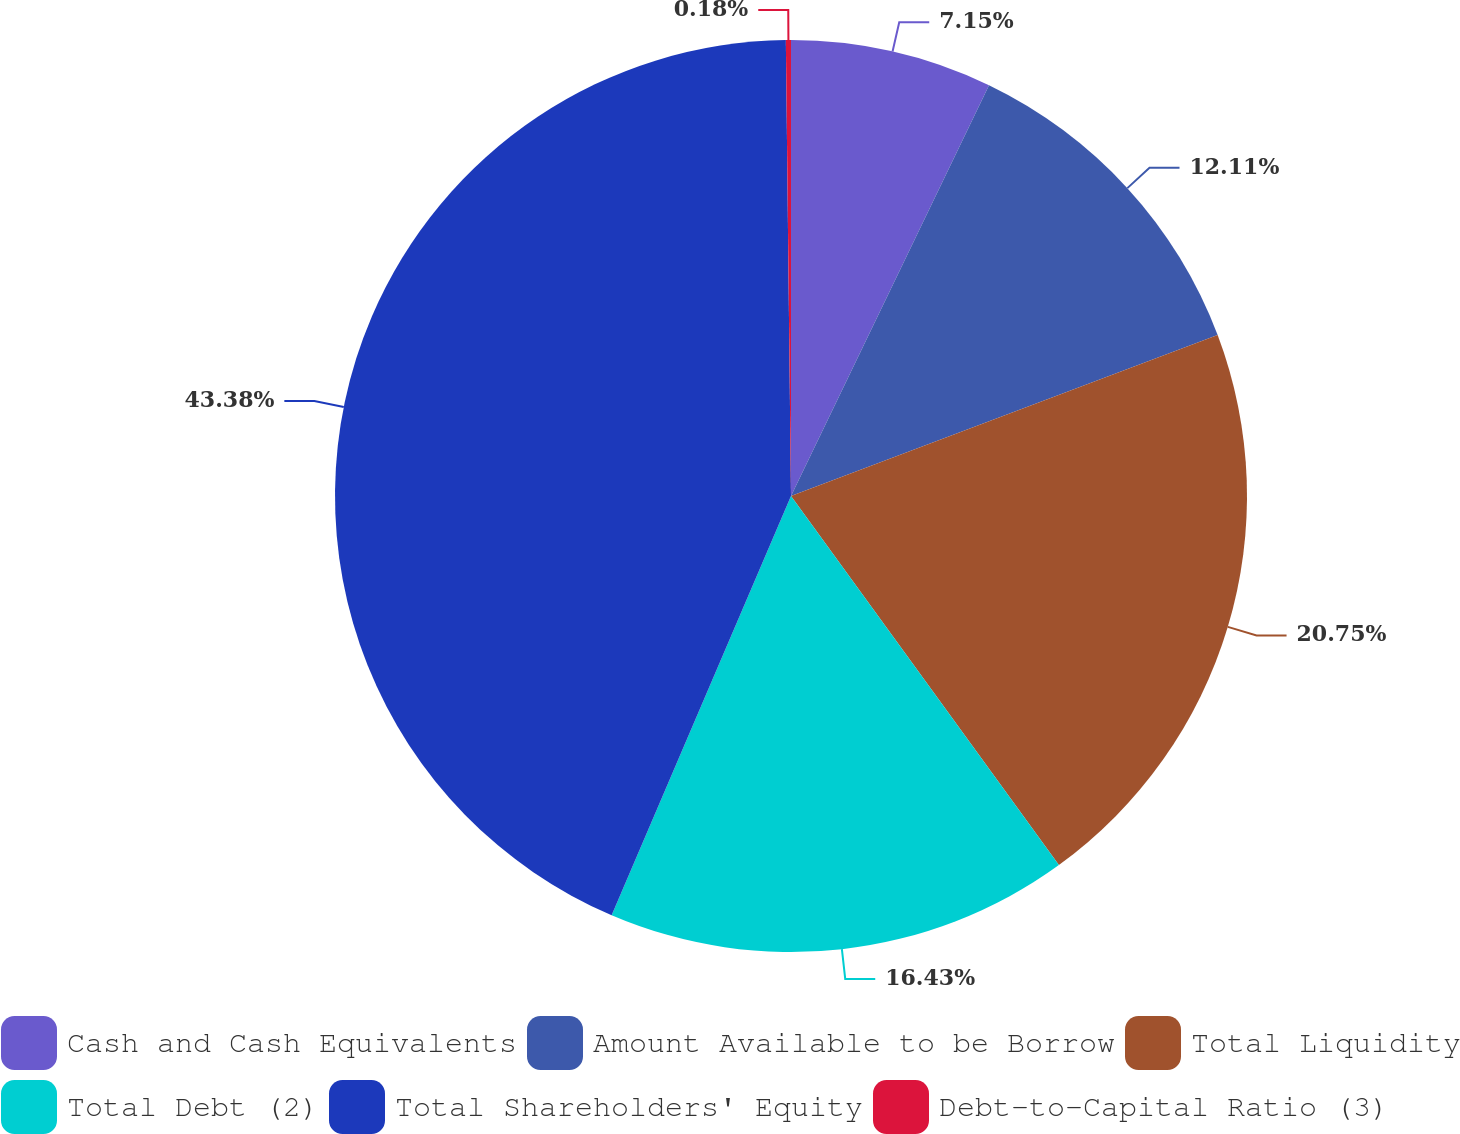<chart> <loc_0><loc_0><loc_500><loc_500><pie_chart><fcel>Cash and Cash Equivalents<fcel>Amount Available to be Borrow<fcel>Total Liquidity<fcel>Total Debt (2)<fcel>Total Shareholders' Equity<fcel>Debt-to-Capital Ratio (3)<nl><fcel>7.15%<fcel>12.11%<fcel>20.75%<fcel>16.43%<fcel>43.39%<fcel>0.18%<nl></chart> 